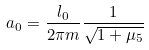<formula> <loc_0><loc_0><loc_500><loc_500>a _ { 0 } = \frac { l _ { 0 } } { 2 \pi m } \frac { 1 } { \sqrt { 1 + \mu _ { 5 } } }</formula> 